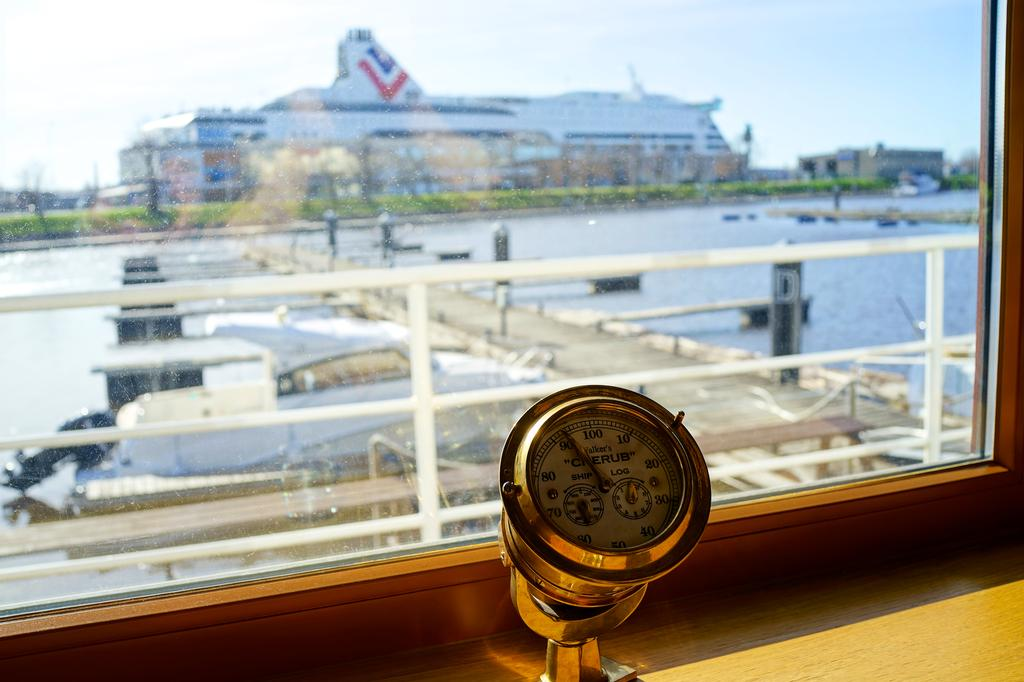<image>
Relay a brief, clear account of the picture shown. A brass Walker's Cherub gauge is sitting in front of a window with a cruise ship in the background.. 